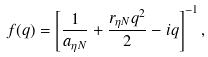Convert formula to latex. <formula><loc_0><loc_0><loc_500><loc_500>f ( q ) = \left [ \frac { 1 } { a _ { \eta N } } + \frac { r _ { \eta N } q ^ { 2 } } { 2 } - i q \right ] ^ { - 1 } ,</formula> 